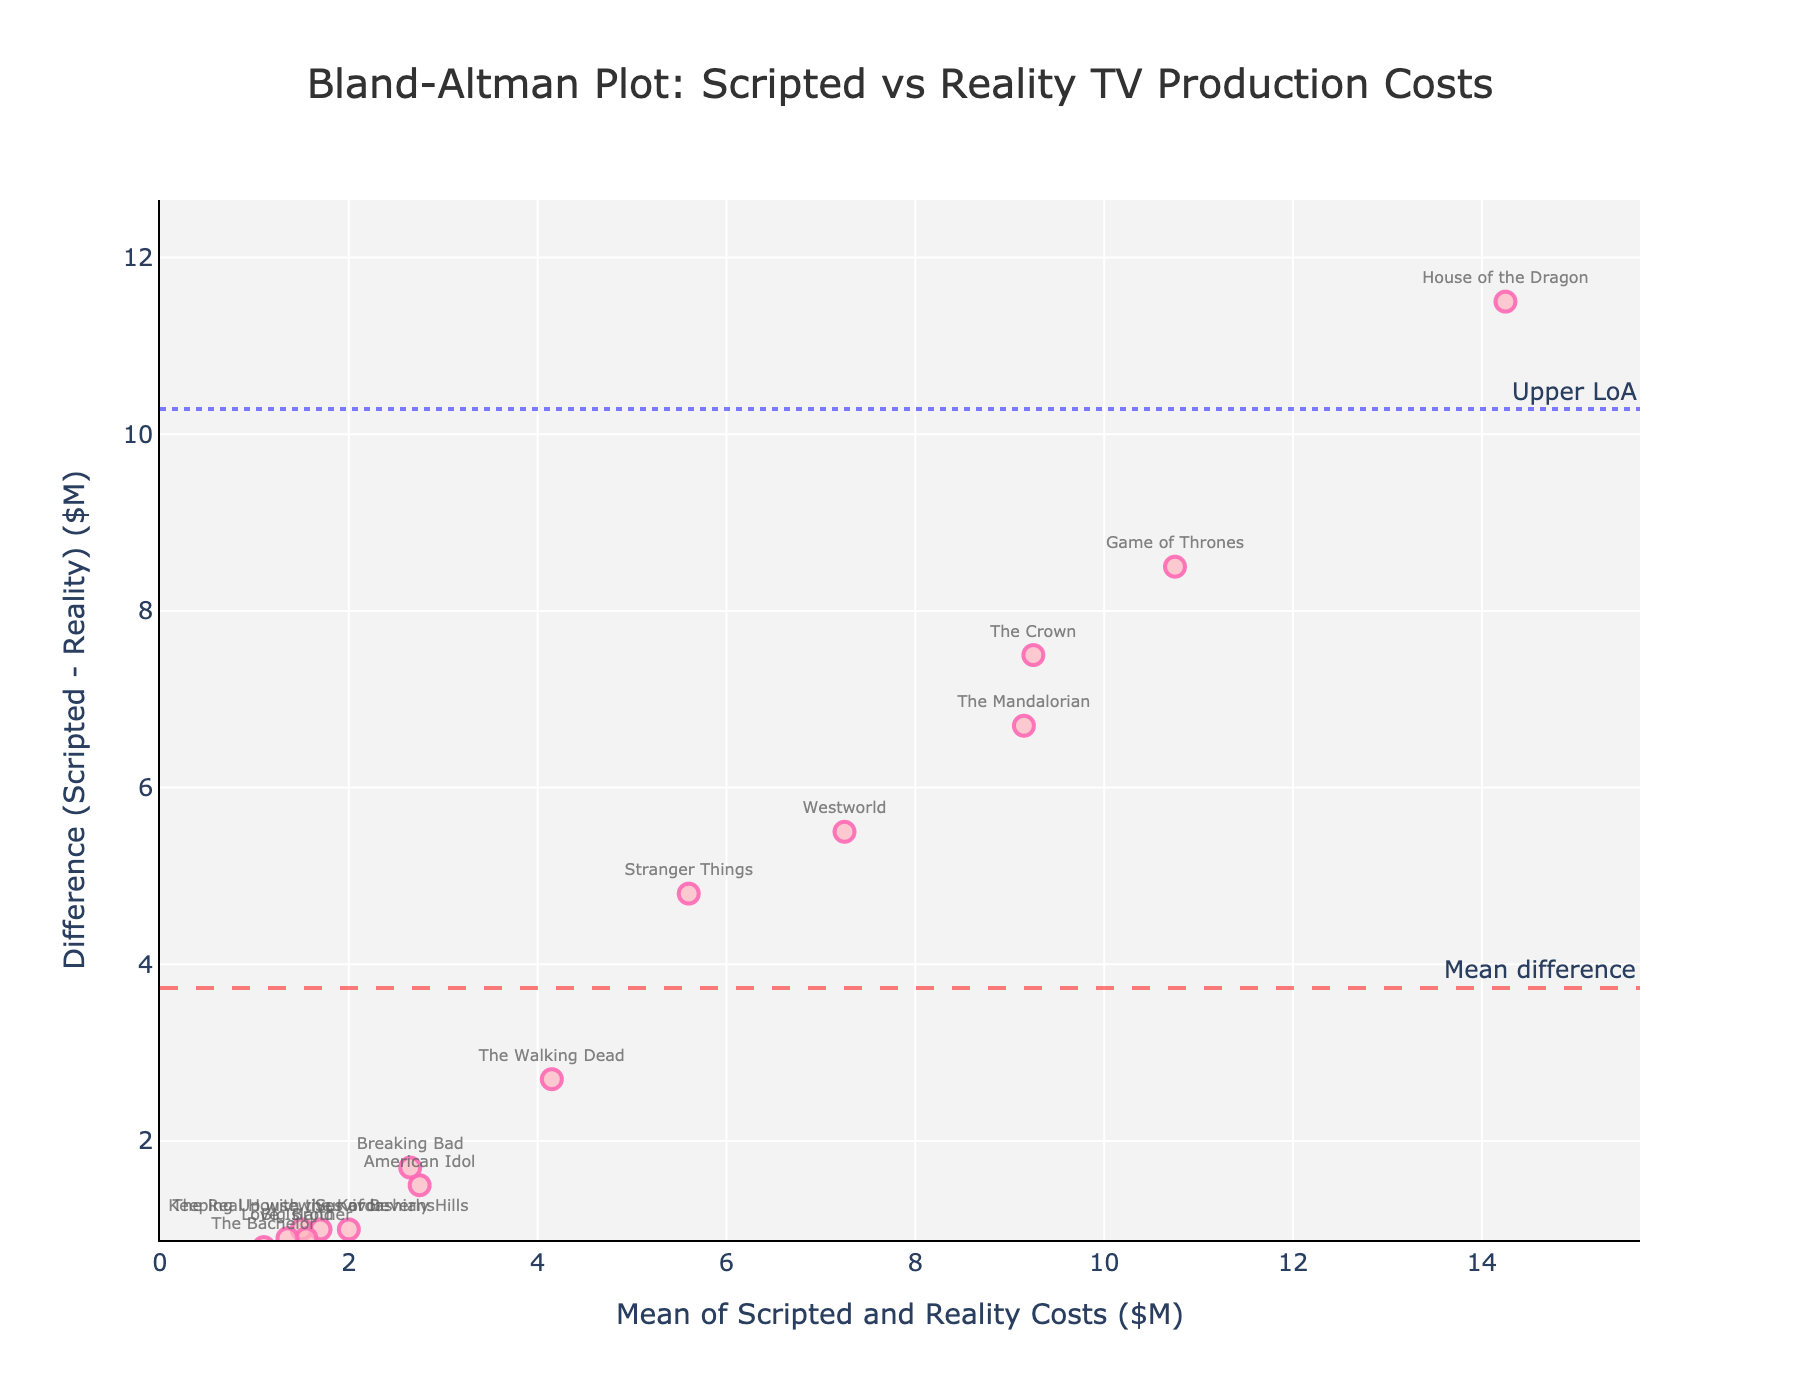What is the title of the Bland-Altman plot? The title is usually located at the top of the plot. Here, the title clearly states the comparison being made.
Answer: Bland-Altman Plot: Scripted vs Reality TV Production Costs Which TV show had the highest mean cost? Examine the x-axis, which represents the mean of scripted and reality costs. The data point farthest to the right belongs to the TV show with the highest mean cost.
Answer: House of the Dragon How much is the mean difference between scripted and reality costs? The mean difference is indicated by the horizontal dashed line labeled "Mean difference" in the plot.
Answer: Approximately 5.8 million dollars What are the limits of agreement (LoA) for the difference in costs? The limits of agreement are represented by the dotted lines labeled "Lower LoA" and "Upper LoA." These lines show the range within which most differences fall.
Answer: Approximately -0.28 and 11.88 million dollars Which two TV shows are closest to the mean difference line? Identify points closest to the horizontal dashed line indicating the mean difference. Check the show names closest to this line.
Answer: Big Brother and Keeping Up with the Kardashians Which TV show has the largest difference in production costs between scripted and reality versions? The largest difference in production costs can be found by identifying the point farthest from the mean difference line vertically.
Answer: House of the Dragon How do the costs of "Game of Thrones" compare to those of "The Bachelor"? Look at the positions of these points relative to their mean cost and difference in the Bland-Altman plot. "Game of Thrones" should be higher on the y-axis compared to "The Bachelor."
Answer: Game of Thrones has higher costs Are there any shows where the production costs are equal for both scripted and reality versions? On the Bland-Altman plot, this would mean a difference of zero, so check for any points lying directly on the x-axis (y=0).
Answer: No What is the approximate standard deviation of the differences in production costs? The standard deviation can be estimated by measuring the spread of the differences around the mean difference.
Answer: Approximately 3 million dollars (half the range of limits of agreement) Which data point stands out the most as an outlier? An outlier will appear farthest away from the mean difference line and the limits of agreement lines.
Answer: House of the Dragon 